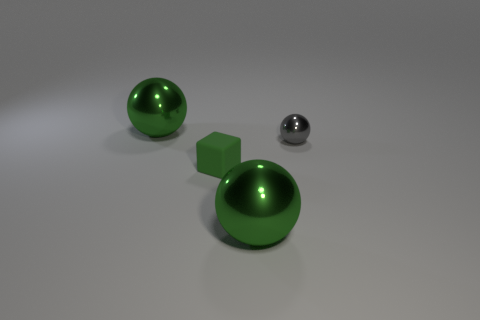There is a tiny shiny ball; is its color the same as the ball in front of the green matte object?
Your answer should be very brief. No. What number of balls are big green things or tiny green matte objects?
Your answer should be very brief. 2. Are there any other things that are the same color as the tiny sphere?
Provide a short and direct response. No. What material is the large ball that is in front of the large thing that is behind the tiny green rubber cube?
Keep it short and to the point. Metal. Are the tiny sphere and the tiny thing in front of the small gray metallic sphere made of the same material?
Provide a short and direct response. No. How many things are big green spheres in front of the small shiny sphere or tiny objects?
Offer a very short reply. 3. Are there any other small things that have the same color as the tiny metal thing?
Offer a terse response. No. There is a small green object; is it the same shape as the big green metallic thing that is in front of the small metal thing?
Your answer should be compact. No. How many objects are both to the right of the green cube and in front of the small gray ball?
Your answer should be compact. 1. There is a ball that is on the right side of the green shiny object that is on the right side of the tiny green rubber block; how big is it?
Provide a succinct answer. Small. 